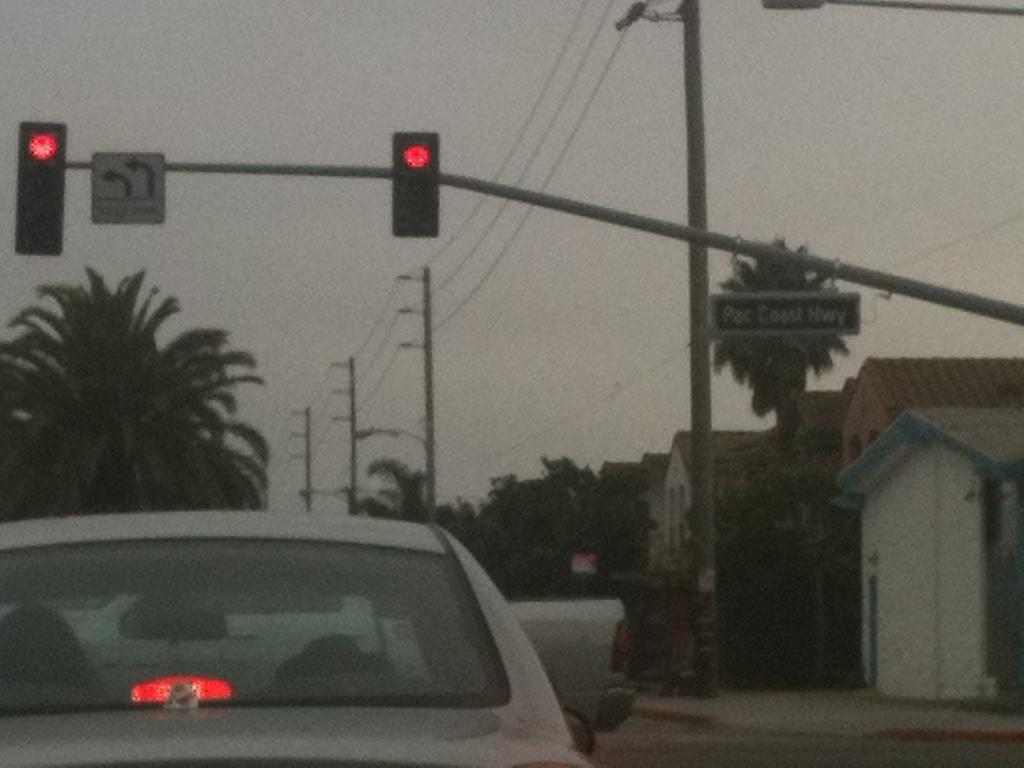<image>
Render a clear and concise summary of the photo. a pac coast highway sign is above the road 